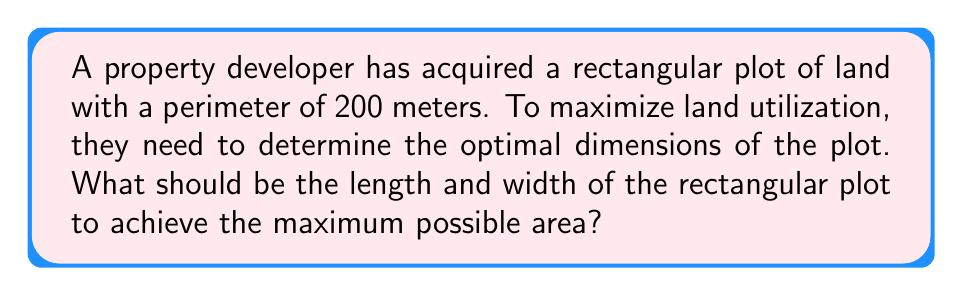Teach me how to tackle this problem. Let's approach this step-by-step:

1) Let $x$ be the width and $y$ be the length of the rectangle.

2) Given that the perimeter is 200 meters, we can write:
   $$2x + 2y = 200$$
   $$x + y = 100$$

3) We can express $y$ in terms of $x$:
   $$y = 100 - x$$

4) The area of the rectangle is given by:
   $$A = xy = x(100-x) = 100x - x^2$$

5) To find the maximum area, we need to find the vertex of this quadratic function. We can do this by finding where the derivative equals zero:

   $$\frac{dA}{dx} = 100 - 2x$$

6) Set this equal to zero and solve:
   $$100 - 2x = 0$$
   $$2x = 100$$
   $$x = 50$$

7) Since the second derivative $\frac{d^2A}{dx^2} = -2$ is negative, this critical point is a maximum.

8) If $x = 50$, then $y = 100 - 50 = 50$

9) Therefore, the optimal dimensions are 50 meters by 50 meters.

10) We can verify that this indeed gives the maximum area:
    $$A = 50 * 50 = 2500 \text{ square meters}$$

[asy]
unitsize(1cm);
draw((0,0)--(5,0)--(5,5)--(0,5)--cycle);
label("50 m", (2.5,0), S);
label("50 m", (0,2.5), W);
label("Area = 2500 sq m", (2.5,2.5));
[/asy]
Answer: 50 meters by 50 meters 